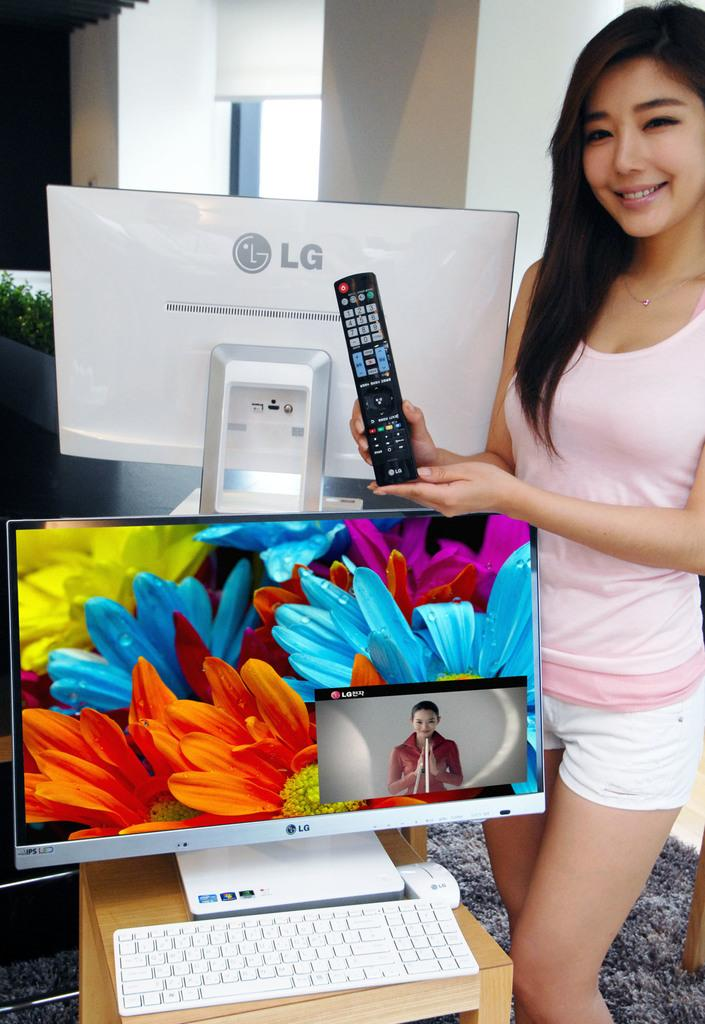Provide a one-sentence caption for the provided image. A girl showcasing an LG remote and standing beside an LG computer. 